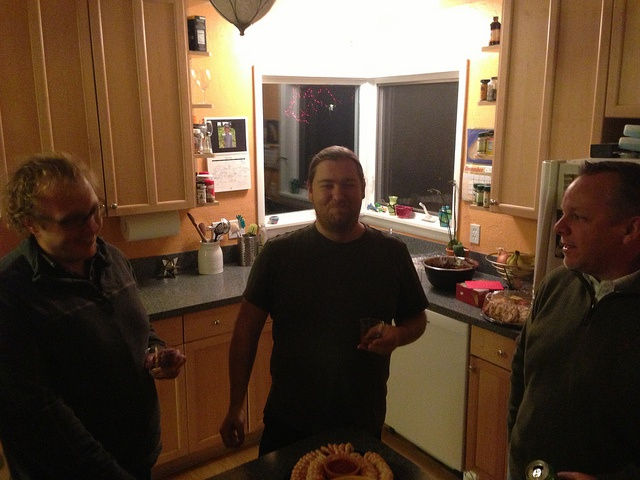Describe the objects in this image and their specific colors. I can see people in maroon, black, and gray tones, people in maroon, black, and gray tones, people in maroon, black, and gray tones, refrigerator in maroon and gray tones, and bowl in maroon, black, and brown tones in this image. 